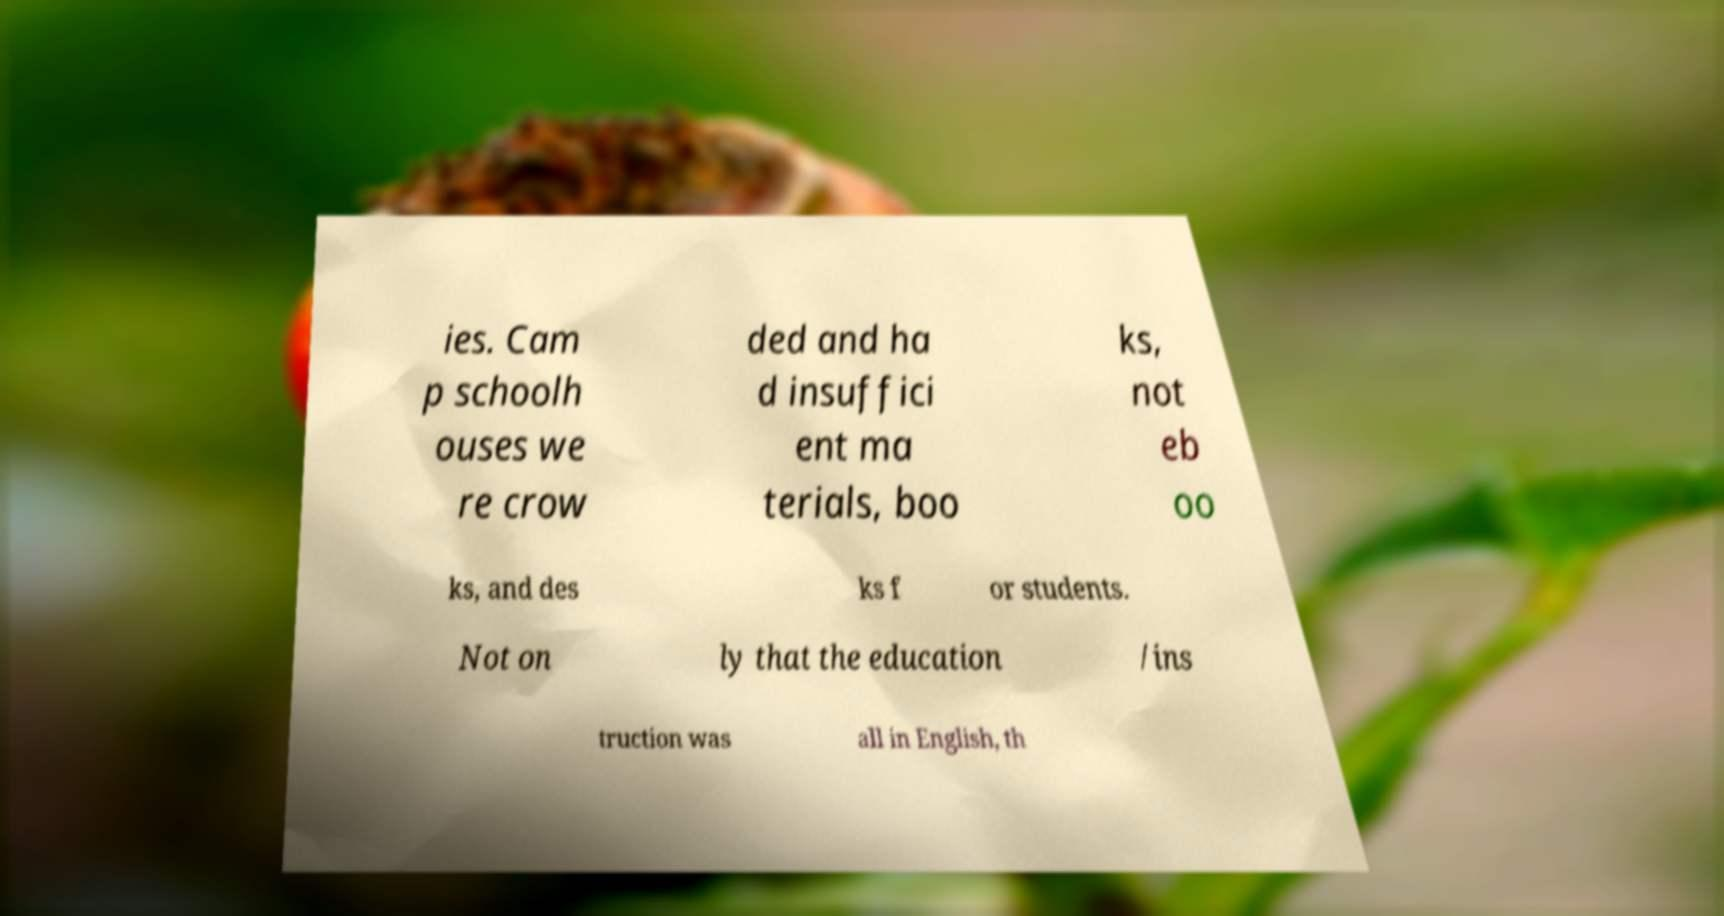I need the written content from this picture converted into text. Can you do that? ies. Cam p schoolh ouses we re crow ded and ha d insuffici ent ma terials, boo ks, not eb oo ks, and des ks f or students. Not on ly that the education /ins truction was all in English, th 